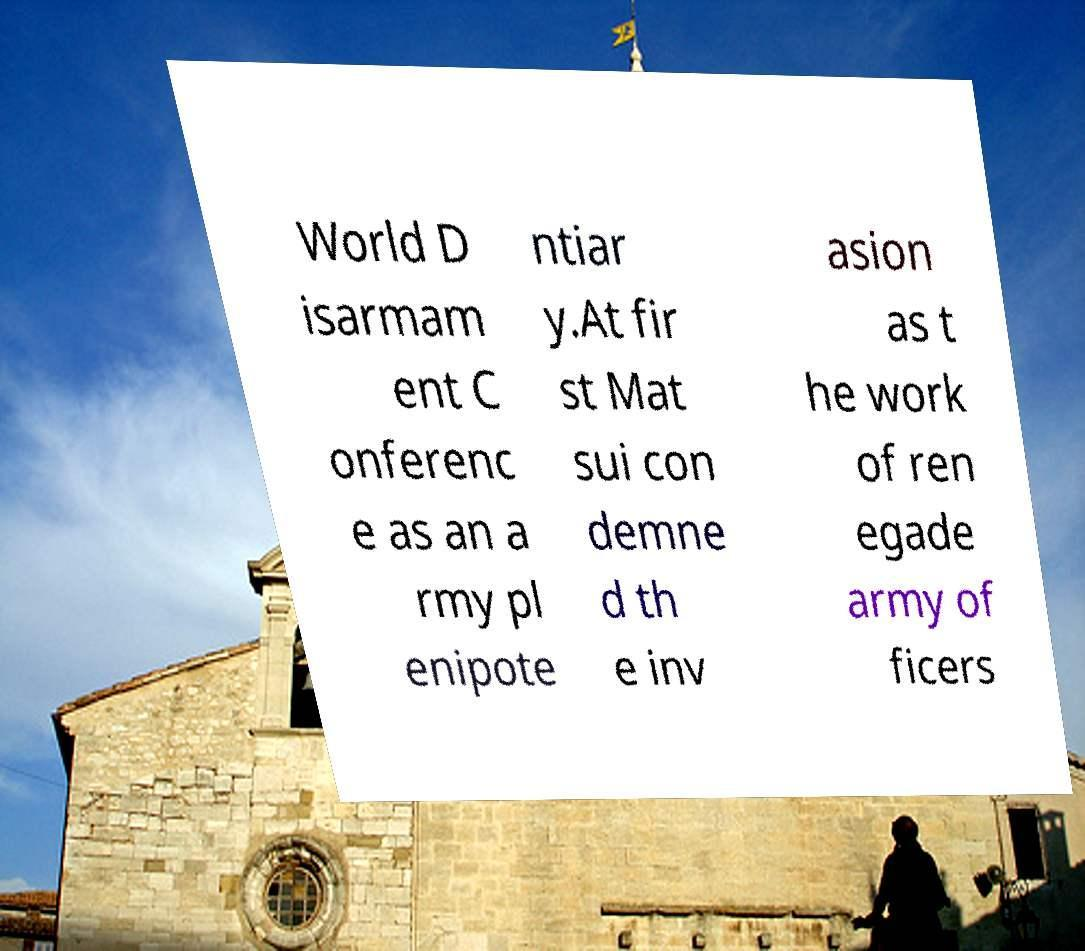There's text embedded in this image that I need extracted. Can you transcribe it verbatim? World D isarmam ent C onferenc e as an a rmy pl enipote ntiar y.At fir st Mat sui con demne d th e inv asion as t he work of ren egade army of ficers 